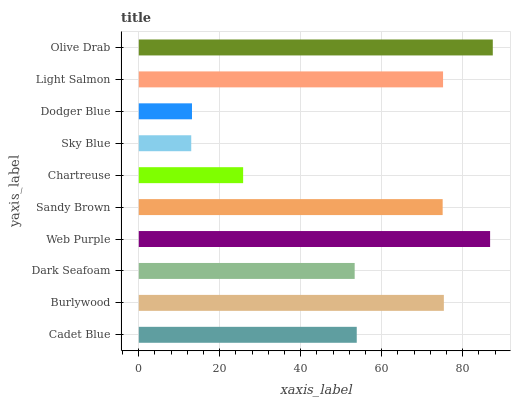Is Sky Blue the minimum?
Answer yes or no. Yes. Is Olive Drab the maximum?
Answer yes or no. Yes. Is Burlywood the minimum?
Answer yes or no. No. Is Burlywood the maximum?
Answer yes or no. No. Is Burlywood greater than Cadet Blue?
Answer yes or no. Yes. Is Cadet Blue less than Burlywood?
Answer yes or no. Yes. Is Cadet Blue greater than Burlywood?
Answer yes or no. No. Is Burlywood less than Cadet Blue?
Answer yes or no. No. Is Sandy Brown the high median?
Answer yes or no. Yes. Is Cadet Blue the low median?
Answer yes or no. Yes. Is Light Salmon the high median?
Answer yes or no. No. Is Sandy Brown the low median?
Answer yes or no. No. 